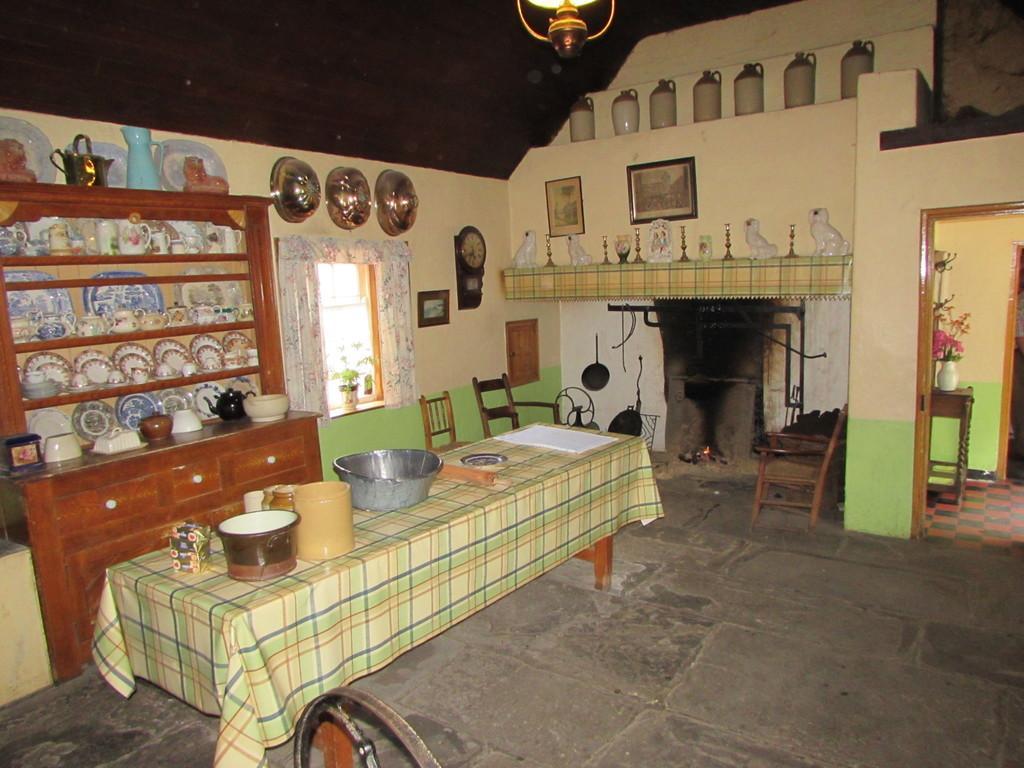Can you describe this image briefly? In the image there is a dining table on the left side with cloth on it and vessels over it, behind it there is a rack with many bowls,plates and jars in it, in the back there are jars and idols on the shelves with photograph and clock on the wall, on the right side there is door with a flower vase. 